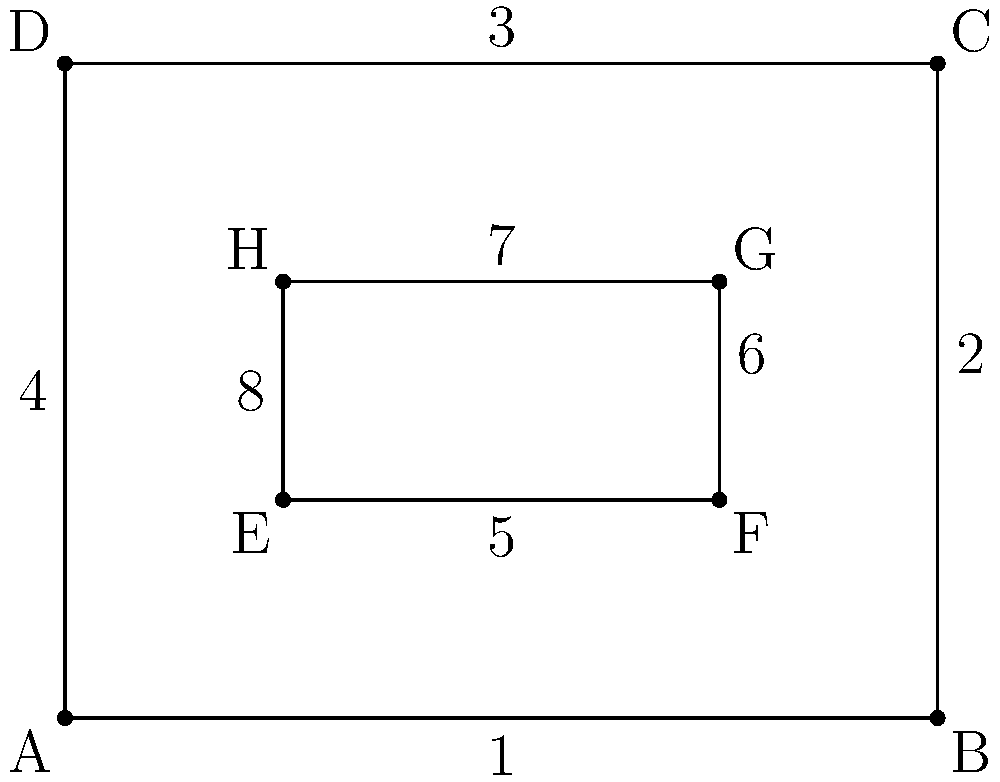In the diagram above, which represents a simple layout of a storm shelter, identify all pairs of congruent sides. List your answer using the numbers assigned to each side. To identify congruent sides in the diagram, we need to analyze the properties of rectangles and compare the sides:

1. The outer shape ABCD is a rectangle, which means:
   - Opposite sides are congruent
   - All angles are 90 degrees

2. The inner shape EFGH is also a rectangle, with the same properties.

3. Let's identify the congruent pairs:
   - Sides 1 and 3 are congruent (opposite sides of the outer rectangle)
   - Sides 2 and 4 are congruent (opposite sides of the outer rectangle)
   - Sides 5 and 7 are congruent (opposite sides of the inner rectangle)
   - Sides 6 and 8 are congruent (opposite sides of the inner rectangle)

4. Note that sides 1 and 3 are not congruent to sides 5 and 7, as they have different lengths. Similarly, sides 2 and 4 are not congruent to sides 6 and 8.

Therefore, the congruent pairs are: (1,3), (2,4), (5,7), and (6,8).
Answer: (1,3), (2,4), (5,7), (6,8) 